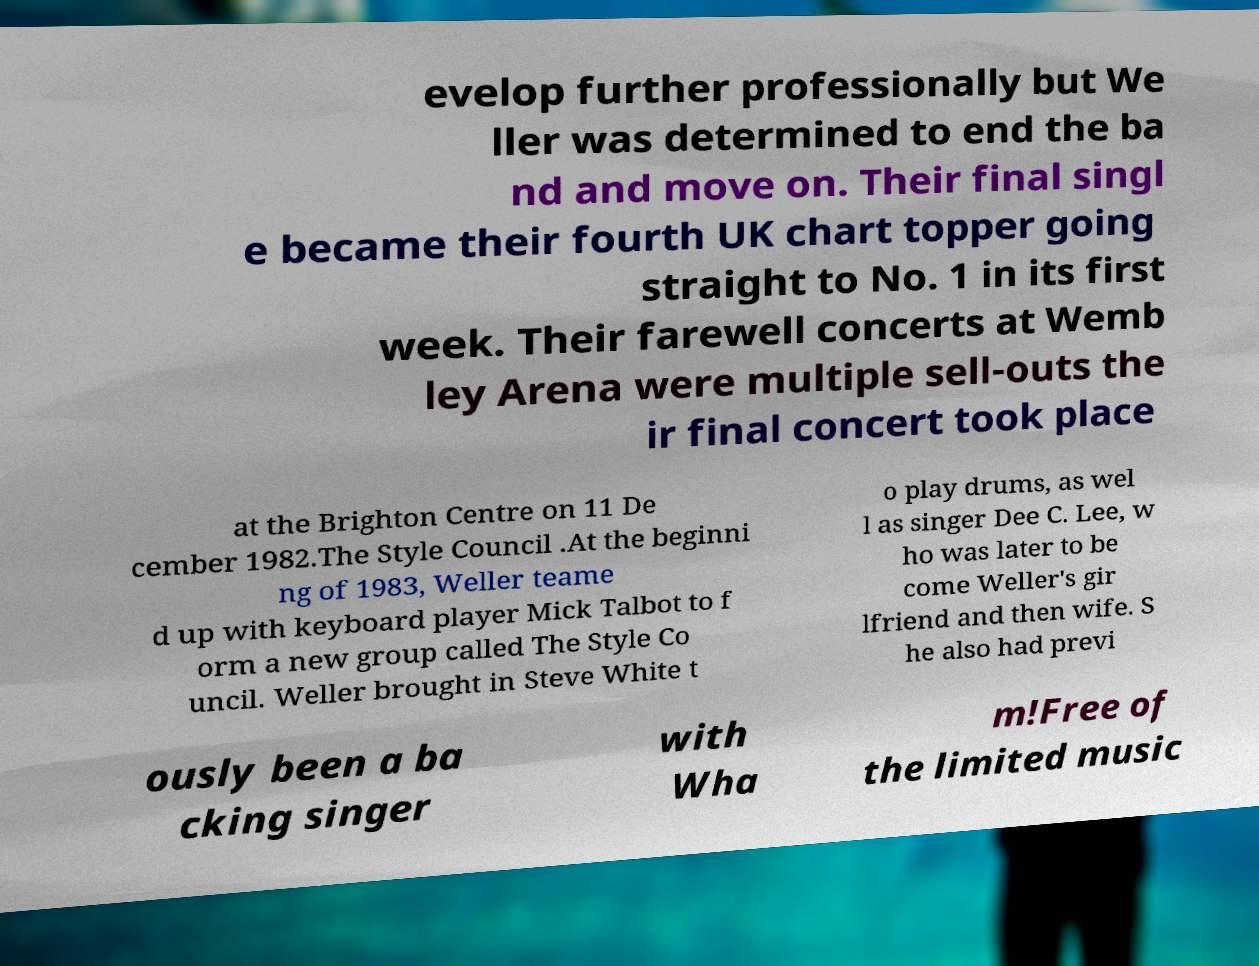Could you assist in decoding the text presented in this image and type it out clearly? evelop further professionally but We ller was determined to end the ba nd and move on. Their final singl e became their fourth UK chart topper going straight to No. 1 in its first week. Their farewell concerts at Wemb ley Arena were multiple sell-outs the ir final concert took place at the Brighton Centre on 11 De cember 1982.The Style Council .At the beginni ng of 1983, Weller teame d up with keyboard player Mick Talbot to f orm a new group called The Style Co uncil. Weller brought in Steve White t o play drums, as wel l as singer Dee C. Lee, w ho was later to be come Weller's gir lfriend and then wife. S he also had previ ously been a ba cking singer with Wha m!Free of the limited music 